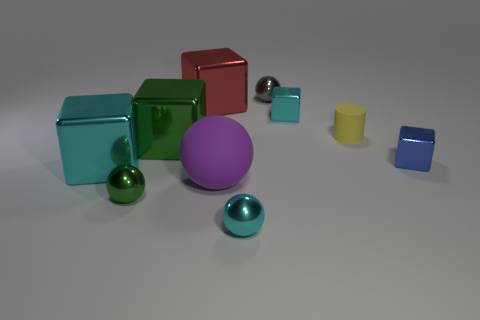Do the big green object and the ball that is behind the rubber sphere have the same material?
Provide a succinct answer. Yes. How many other things are the same shape as the tiny gray object?
Your answer should be very brief. 3. The small sphere that is on the left side of the small metallic sphere in front of the small sphere left of the big rubber object is made of what material?
Provide a succinct answer. Metal. Are there the same number of objects to the left of the blue thing and tiny blue blocks?
Your answer should be compact. No. Does the cyan block on the right side of the big red metallic cube have the same material as the sphere that is left of the big red shiny object?
Ensure brevity in your answer.  Yes. Is there anything else that is the same material as the purple object?
Offer a terse response. Yes. Is the shape of the cyan shiny object that is behind the small blue shiny cube the same as the green metal thing behind the small green ball?
Your answer should be very brief. Yes. Are there fewer small metallic blocks that are behind the gray object than shiny spheres?
Ensure brevity in your answer.  Yes. How many tiny metal blocks have the same color as the tiny cylinder?
Make the answer very short. 0. What size is the sphere that is behind the red block?
Ensure brevity in your answer.  Small. 